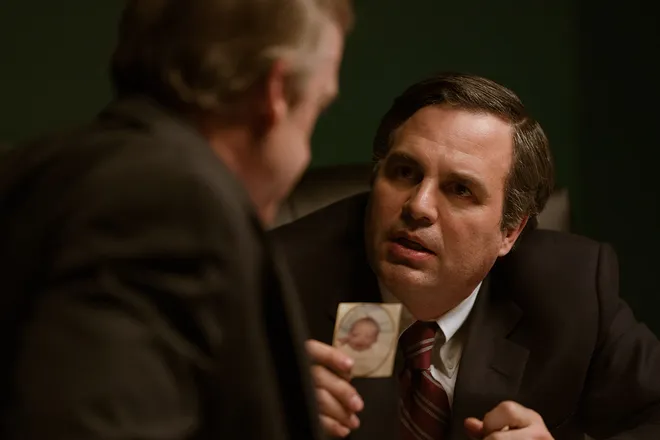Imagine that the photograph being held is of something unexpected. What could it be and how would it change the context of the scene? Let's imagine the photograph is of an extraterrestrial being. This twist could transform the scene entirely, suggesting a secret meeting discussing classified information about alien life. Suddenly, Rob Bilott's intense plea might be about convincing the other man to disclose or take action on the discovery of extraterrestrial existence. This would add a science fiction element to the narrative, turning a seemingly serious drama into a thrilling, speculative scenario. What do you think Rob Bilott’s character is trying to convey in this moment? Rob Bilott, portrayed by Mark Ruffalo, seems to be in the midst of making a passionate, possibly desperate, argument. His expression conveys deep concern and determination, suggesting that he’s trying to persuade the other man of something crucial. Given the context of the movie 'Dark Waters', he might be urging the other person to understand the severity of the chemical contamination case he is investigating, emphasizing the human cost and environmental impact. Detail the possible emotional state and motivation of the character played by Mark Ruffalo. In this intense scene, Rob Bilott's emotional state seems to be a blend of frustration, urgency, and determination. He is likely under considerable stress, knowing that the stakes are high. His motivation stems from a deep sense of justice and an unwavering commitment to uncover the truth. He is driven by the desire to protect the public from harm and to expose the wrongdoing of a powerful corporation. His body language and the earnest expression on his face convey a man who won’t take no for an answer, someone who is fighting against a seemingly insurmountable challenge. 